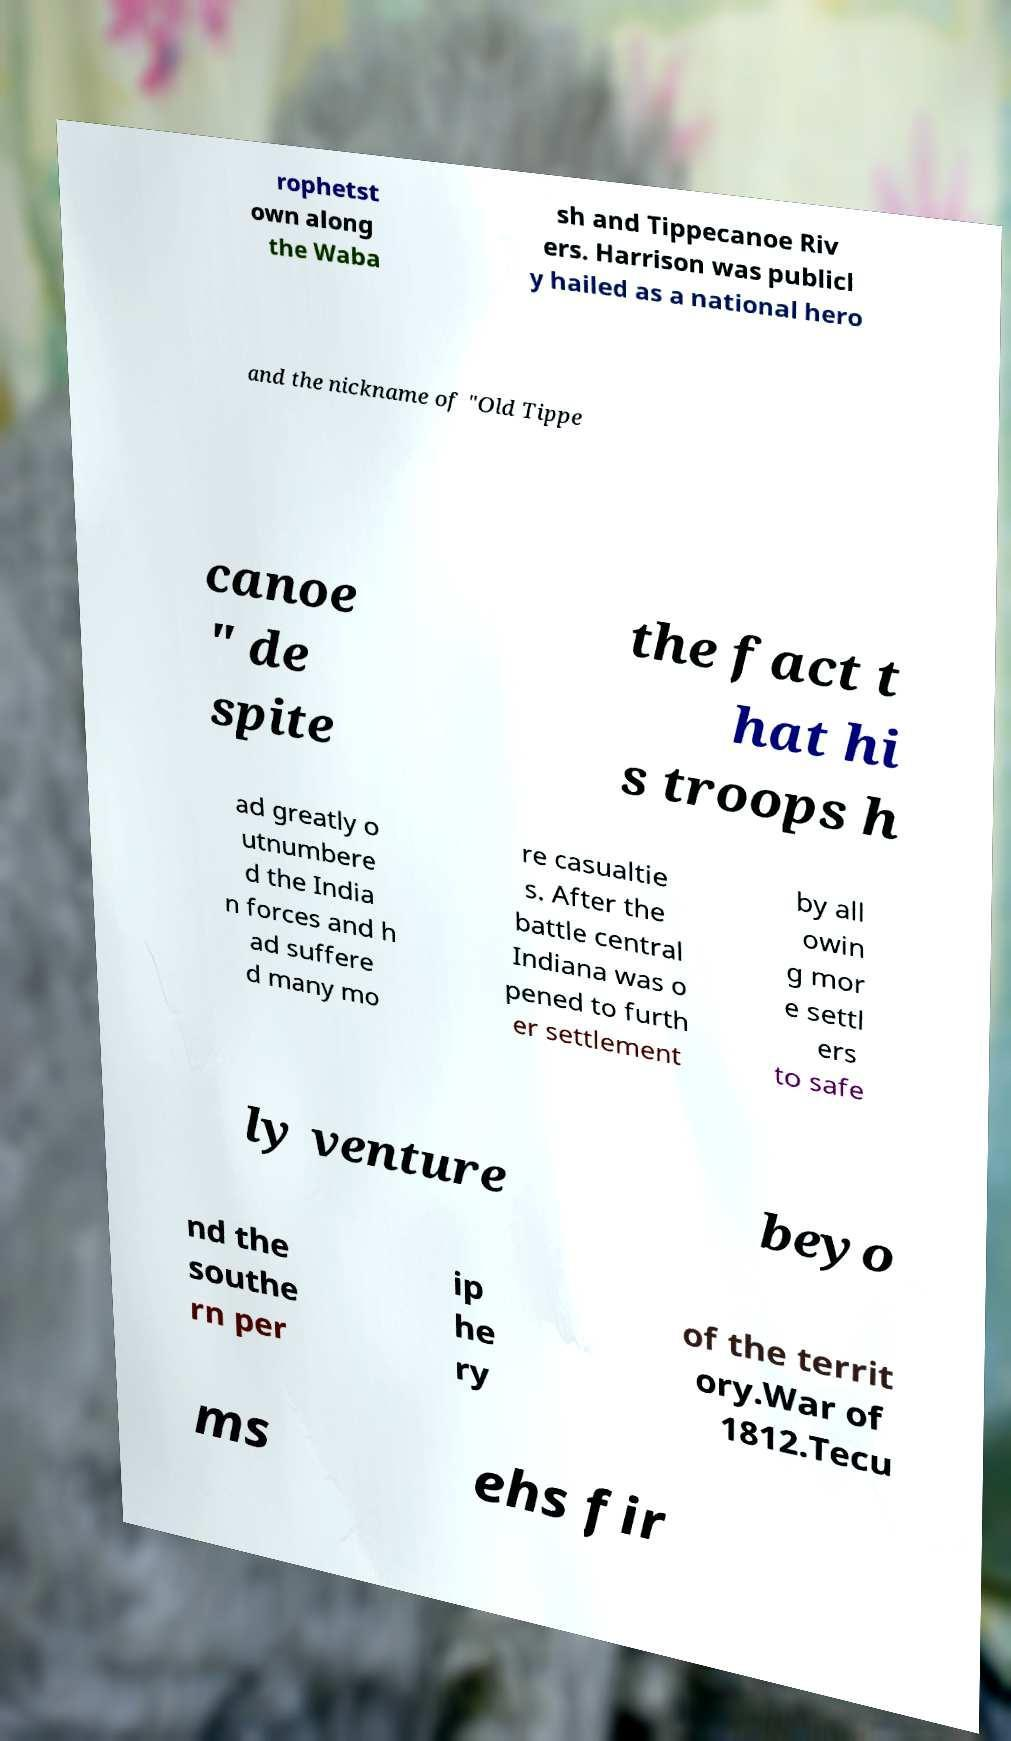Could you extract and type out the text from this image? rophetst own along the Waba sh and Tippecanoe Riv ers. Harrison was publicl y hailed as a national hero and the nickname of "Old Tippe canoe " de spite the fact t hat hi s troops h ad greatly o utnumbere d the India n forces and h ad suffere d many mo re casualtie s. After the battle central Indiana was o pened to furth er settlement by all owin g mor e settl ers to safe ly venture beyo nd the southe rn per ip he ry of the territ ory.War of 1812.Tecu ms ehs fir 